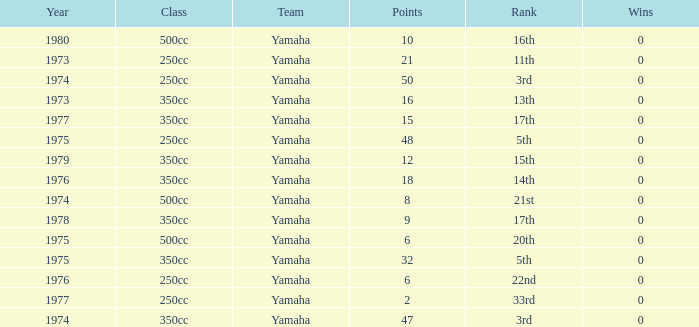Which points is the least one with a year beyond 1974 and a rank of 15th? 12.0. 